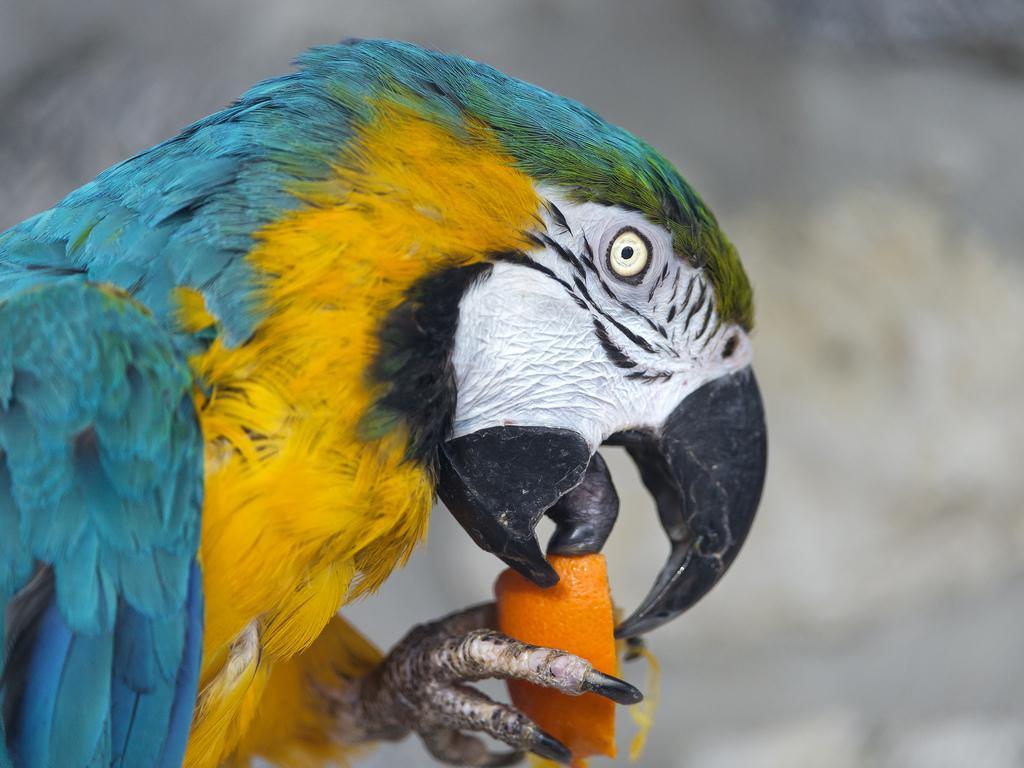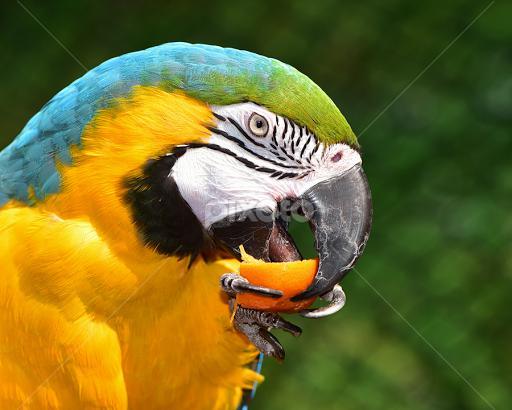The first image is the image on the left, the second image is the image on the right. Given the left and right images, does the statement "On one image, there's a parrot perched on a branch." hold true? Answer yes or no. No. The first image is the image on the left, the second image is the image on the right. Examine the images to the left and right. Is the description "The birds in both images have predominantly blue and yellow coloring" accurate? Answer yes or no. Yes. 